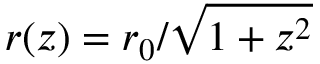Convert formula to latex. <formula><loc_0><loc_0><loc_500><loc_500>r ( z ) = r _ { 0 } / \sqrt { 1 + z ^ { 2 } }</formula> 